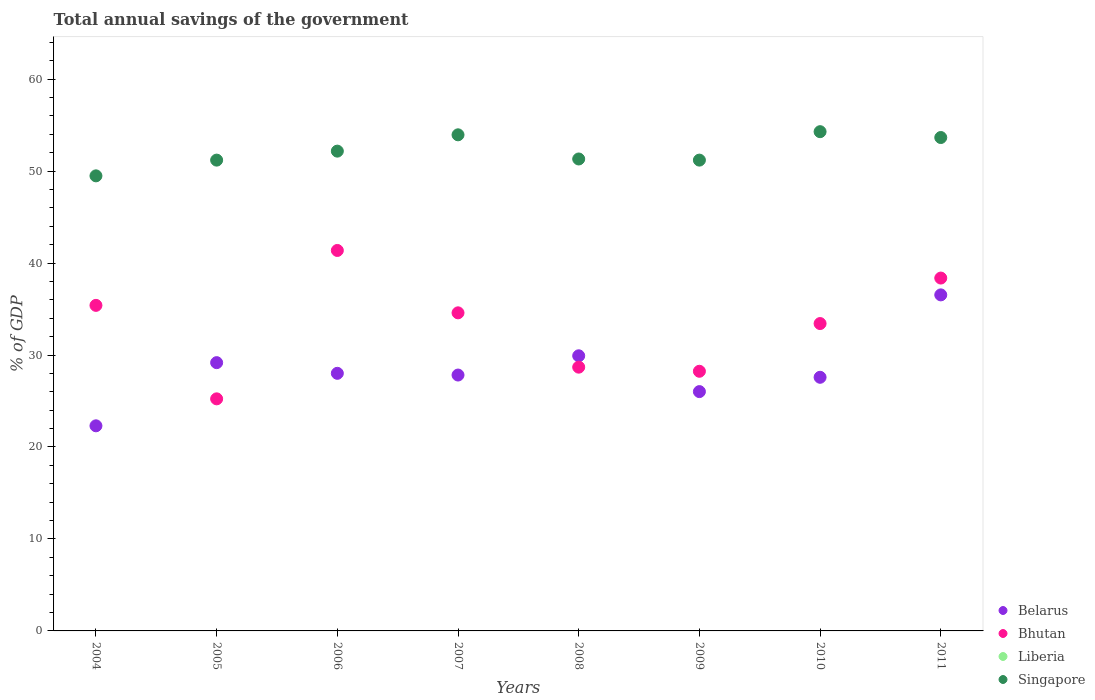How many different coloured dotlines are there?
Provide a succinct answer. 3. Is the number of dotlines equal to the number of legend labels?
Offer a very short reply. No. What is the total annual savings of the government in Singapore in 2009?
Offer a very short reply. 51.2. Across all years, what is the maximum total annual savings of the government in Singapore?
Ensure brevity in your answer.  54.29. Across all years, what is the minimum total annual savings of the government in Singapore?
Ensure brevity in your answer.  49.48. In which year was the total annual savings of the government in Bhutan maximum?
Make the answer very short. 2006. What is the difference between the total annual savings of the government in Bhutan in 2006 and that in 2007?
Ensure brevity in your answer.  6.78. What is the difference between the total annual savings of the government in Singapore in 2006 and the total annual savings of the government in Bhutan in 2008?
Your answer should be compact. 23.49. What is the average total annual savings of the government in Bhutan per year?
Keep it short and to the point. 33.16. In the year 2007, what is the difference between the total annual savings of the government in Bhutan and total annual savings of the government in Singapore?
Keep it short and to the point. -19.36. What is the ratio of the total annual savings of the government in Belarus in 2007 to that in 2011?
Your answer should be compact. 0.76. Is the total annual savings of the government in Bhutan in 2004 less than that in 2011?
Your response must be concise. Yes. Is the difference between the total annual savings of the government in Bhutan in 2008 and 2011 greater than the difference between the total annual savings of the government in Singapore in 2008 and 2011?
Your answer should be very brief. No. What is the difference between the highest and the second highest total annual savings of the government in Belarus?
Your answer should be very brief. 6.62. What is the difference between the highest and the lowest total annual savings of the government in Belarus?
Your answer should be very brief. 14.24. In how many years, is the total annual savings of the government in Liberia greater than the average total annual savings of the government in Liberia taken over all years?
Ensure brevity in your answer.  0. Is the sum of the total annual savings of the government in Singapore in 2007 and 2011 greater than the maximum total annual savings of the government in Bhutan across all years?
Offer a very short reply. Yes. Is it the case that in every year, the sum of the total annual savings of the government in Belarus and total annual savings of the government in Bhutan  is greater than the total annual savings of the government in Liberia?
Ensure brevity in your answer.  Yes. Is the total annual savings of the government in Liberia strictly greater than the total annual savings of the government in Singapore over the years?
Ensure brevity in your answer.  No. Is the total annual savings of the government in Bhutan strictly less than the total annual savings of the government in Singapore over the years?
Offer a very short reply. Yes. What is the difference between two consecutive major ticks on the Y-axis?
Ensure brevity in your answer.  10. Where does the legend appear in the graph?
Your response must be concise. Bottom right. How many legend labels are there?
Your response must be concise. 4. What is the title of the graph?
Ensure brevity in your answer.  Total annual savings of the government. What is the label or title of the Y-axis?
Ensure brevity in your answer.  % of GDP. What is the % of GDP in Belarus in 2004?
Keep it short and to the point. 22.3. What is the % of GDP in Bhutan in 2004?
Provide a succinct answer. 35.4. What is the % of GDP in Liberia in 2004?
Provide a succinct answer. 0. What is the % of GDP in Singapore in 2004?
Your answer should be very brief. 49.48. What is the % of GDP in Belarus in 2005?
Make the answer very short. 29.17. What is the % of GDP in Bhutan in 2005?
Your answer should be very brief. 25.24. What is the % of GDP in Singapore in 2005?
Your response must be concise. 51.2. What is the % of GDP of Belarus in 2006?
Your answer should be very brief. 28.01. What is the % of GDP of Bhutan in 2006?
Your response must be concise. 41.37. What is the % of GDP of Liberia in 2006?
Keep it short and to the point. 0. What is the % of GDP of Singapore in 2006?
Ensure brevity in your answer.  52.17. What is the % of GDP of Belarus in 2007?
Your response must be concise. 27.82. What is the % of GDP in Bhutan in 2007?
Keep it short and to the point. 34.59. What is the % of GDP of Singapore in 2007?
Your answer should be compact. 53.95. What is the % of GDP of Belarus in 2008?
Provide a short and direct response. 29.92. What is the % of GDP of Bhutan in 2008?
Ensure brevity in your answer.  28.68. What is the % of GDP in Singapore in 2008?
Your response must be concise. 51.32. What is the % of GDP of Belarus in 2009?
Give a very brief answer. 26.02. What is the % of GDP of Bhutan in 2009?
Offer a terse response. 28.23. What is the % of GDP of Singapore in 2009?
Your answer should be very brief. 51.2. What is the % of GDP in Belarus in 2010?
Offer a very short reply. 27.58. What is the % of GDP of Bhutan in 2010?
Offer a terse response. 33.42. What is the % of GDP of Liberia in 2010?
Make the answer very short. 0. What is the % of GDP in Singapore in 2010?
Your response must be concise. 54.29. What is the % of GDP in Belarus in 2011?
Give a very brief answer. 36.54. What is the % of GDP in Bhutan in 2011?
Ensure brevity in your answer.  38.37. What is the % of GDP of Liberia in 2011?
Offer a terse response. 0. What is the % of GDP in Singapore in 2011?
Your answer should be compact. 53.65. Across all years, what is the maximum % of GDP in Belarus?
Your answer should be compact. 36.54. Across all years, what is the maximum % of GDP of Bhutan?
Offer a very short reply. 41.37. Across all years, what is the maximum % of GDP of Singapore?
Make the answer very short. 54.29. Across all years, what is the minimum % of GDP of Belarus?
Provide a succinct answer. 22.3. Across all years, what is the minimum % of GDP in Bhutan?
Your answer should be compact. 25.24. Across all years, what is the minimum % of GDP in Singapore?
Your response must be concise. 49.48. What is the total % of GDP of Belarus in the graph?
Offer a very short reply. 227.37. What is the total % of GDP in Bhutan in the graph?
Give a very brief answer. 265.31. What is the total % of GDP of Liberia in the graph?
Your answer should be very brief. 0. What is the total % of GDP of Singapore in the graph?
Ensure brevity in your answer.  417.25. What is the difference between the % of GDP of Belarus in 2004 and that in 2005?
Give a very brief answer. -6.87. What is the difference between the % of GDP in Bhutan in 2004 and that in 2005?
Keep it short and to the point. 10.16. What is the difference between the % of GDP of Singapore in 2004 and that in 2005?
Provide a short and direct response. -1.71. What is the difference between the % of GDP in Belarus in 2004 and that in 2006?
Give a very brief answer. -5.71. What is the difference between the % of GDP of Bhutan in 2004 and that in 2006?
Give a very brief answer. -5.97. What is the difference between the % of GDP in Singapore in 2004 and that in 2006?
Offer a terse response. -2.69. What is the difference between the % of GDP in Belarus in 2004 and that in 2007?
Ensure brevity in your answer.  -5.52. What is the difference between the % of GDP of Bhutan in 2004 and that in 2007?
Offer a terse response. 0.81. What is the difference between the % of GDP of Singapore in 2004 and that in 2007?
Offer a terse response. -4.46. What is the difference between the % of GDP of Belarus in 2004 and that in 2008?
Provide a short and direct response. -7.61. What is the difference between the % of GDP in Bhutan in 2004 and that in 2008?
Make the answer very short. 6.72. What is the difference between the % of GDP of Singapore in 2004 and that in 2008?
Offer a terse response. -1.83. What is the difference between the % of GDP of Belarus in 2004 and that in 2009?
Keep it short and to the point. -3.72. What is the difference between the % of GDP of Bhutan in 2004 and that in 2009?
Ensure brevity in your answer.  7.17. What is the difference between the % of GDP in Singapore in 2004 and that in 2009?
Provide a short and direct response. -1.71. What is the difference between the % of GDP of Belarus in 2004 and that in 2010?
Make the answer very short. -5.28. What is the difference between the % of GDP in Bhutan in 2004 and that in 2010?
Ensure brevity in your answer.  1.98. What is the difference between the % of GDP in Singapore in 2004 and that in 2010?
Make the answer very short. -4.8. What is the difference between the % of GDP of Belarus in 2004 and that in 2011?
Provide a short and direct response. -14.24. What is the difference between the % of GDP of Bhutan in 2004 and that in 2011?
Provide a succinct answer. -2.97. What is the difference between the % of GDP of Singapore in 2004 and that in 2011?
Give a very brief answer. -4.17. What is the difference between the % of GDP of Belarus in 2005 and that in 2006?
Give a very brief answer. 1.16. What is the difference between the % of GDP in Bhutan in 2005 and that in 2006?
Ensure brevity in your answer.  -16.14. What is the difference between the % of GDP of Singapore in 2005 and that in 2006?
Give a very brief answer. -0.98. What is the difference between the % of GDP in Belarus in 2005 and that in 2007?
Your response must be concise. 1.35. What is the difference between the % of GDP in Bhutan in 2005 and that in 2007?
Offer a very short reply. -9.35. What is the difference between the % of GDP of Singapore in 2005 and that in 2007?
Provide a short and direct response. -2.75. What is the difference between the % of GDP in Belarus in 2005 and that in 2008?
Offer a very short reply. -0.75. What is the difference between the % of GDP in Bhutan in 2005 and that in 2008?
Offer a terse response. -3.45. What is the difference between the % of GDP of Singapore in 2005 and that in 2008?
Your answer should be compact. -0.12. What is the difference between the % of GDP of Belarus in 2005 and that in 2009?
Offer a terse response. 3.15. What is the difference between the % of GDP of Bhutan in 2005 and that in 2009?
Your answer should be very brief. -3. What is the difference between the % of GDP of Singapore in 2005 and that in 2009?
Your response must be concise. -0. What is the difference between the % of GDP in Belarus in 2005 and that in 2010?
Your answer should be compact. 1.59. What is the difference between the % of GDP of Bhutan in 2005 and that in 2010?
Make the answer very short. -8.19. What is the difference between the % of GDP of Singapore in 2005 and that in 2010?
Your answer should be compact. -3.09. What is the difference between the % of GDP of Belarus in 2005 and that in 2011?
Your answer should be compact. -7.37. What is the difference between the % of GDP in Bhutan in 2005 and that in 2011?
Ensure brevity in your answer.  -13.13. What is the difference between the % of GDP of Singapore in 2005 and that in 2011?
Offer a very short reply. -2.46. What is the difference between the % of GDP in Belarus in 2006 and that in 2007?
Your answer should be very brief. 0.19. What is the difference between the % of GDP in Bhutan in 2006 and that in 2007?
Your answer should be very brief. 6.78. What is the difference between the % of GDP of Singapore in 2006 and that in 2007?
Offer a terse response. -1.77. What is the difference between the % of GDP in Belarus in 2006 and that in 2008?
Keep it short and to the point. -1.91. What is the difference between the % of GDP of Bhutan in 2006 and that in 2008?
Provide a succinct answer. 12.69. What is the difference between the % of GDP in Singapore in 2006 and that in 2008?
Offer a terse response. 0.85. What is the difference between the % of GDP in Belarus in 2006 and that in 2009?
Provide a succinct answer. 1.99. What is the difference between the % of GDP in Bhutan in 2006 and that in 2009?
Provide a succinct answer. 13.14. What is the difference between the % of GDP of Singapore in 2006 and that in 2009?
Offer a very short reply. 0.98. What is the difference between the % of GDP of Belarus in 2006 and that in 2010?
Your response must be concise. 0.43. What is the difference between the % of GDP in Bhutan in 2006 and that in 2010?
Offer a very short reply. 7.95. What is the difference between the % of GDP of Singapore in 2006 and that in 2010?
Your response must be concise. -2.12. What is the difference between the % of GDP of Belarus in 2006 and that in 2011?
Provide a short and direct response. -8.53. What is the difference between the % of GDP of Bhutan in 2006 and that in 2011?
Your response must be concise. 3. What is the difference between the % of GDP in Singapore in 2006 and that in 2011?
Make the answer very short. -1.48. What is the difference between the % of GDP of Belarus in 2007 and that in 2008?
Your response must be concise. -2.09. What is the difference between the % of GDP in Bhutan in 2007 and that in 2008?
Make the answer very short. 5.91. What is the difference between the % of GDP of Singapore in 2007 and that in 2008?
Keep it short and to the point. 2.63. What is the difference between the % of GDP of Belarus in 2007 and that in 2009?
Offer a terse response. 1.8. What is the difference between the % of GDP of Bhutan in 2007 and that in 2009?
Provide a succinct answer. 6.35. What is the difference between the % of GDP in Singapore in 2007 and that in 2009?
Your answer should be very brief. 2.75. What is the difference between the % of GDP in Belarus in 2007 and that in 2010?
Your answer should be compact. 0.24. What is the difference between the % of GDP of Bhutan in 2007 and that in 2010?
Offer a very short reply. 1.16. What is the difference between the % of GDP in Singapore in 2007 and that in 2010?
Your answer should be compact. -0.34. What is the difference between the % of GDP of Belarus in 2007 and that in 2011?
Keep it short and to the point. -8.72. What is the difference between the % of GDP of Bhutan in 2007 and that in 2011?
Provide a succinct answer. -3.78. What is the difference between the % of GDP of Singapore in 2007 and that in 2011?
Offer a terse response. 0.29. What is the difference between the % of GDP of Belarus in 2008 and that in 2009?
Make the answer very short. 3.89. What is the difference between the % of GDP in Bhutan in 2008 and that in 2009?
Keep it short and to the point. 0.45. What is the difference between the % of GDP of Singapore in 2008 and that in 2009?
Offer a very short reply. 0.12. What is the difference between the % of GDP in Belarus in 2008 and that in 2010?
Provide a short and direct response. 2.34. What is the difference between the % of GDP in Bhutan in 2008 and that in 2010?
Offer a terse response. -4.74. What is the difference between the % of GDP of Singapore in 2008 and that in 2010?
Offer a terse response. -2.97. What is the difference between the % of GDP of Belarus in 2008 and that in 2011?
Ensure brevity in your answer.  -6.62. What is the difference between the % of GDP of Bhutan in 2008 and that in 2011?
Your answer should be very brief. -9.69. What is the difference between the % of GDP of Singapore in 2008 and that in 2011?
Make the answer very short. -2.33. What is the difference between the % of GDP in Belarus in 2009 and that in 2010?
Offer a terse response. -1.56. What is the difference between the % of GDP in Bhutan in 2009 and that in 2010?
Offer a very short reply. -5.19. What is the difference between the % of GDP of Singapore in 2009 and that in 2010?
Give a very brief answer. -3.09. What is the difference between the % of GDP in Belarus in 2009 and that in 2011?
Your answer should be compact. -10.52. What is the difference between the % of GDP in Bhutan in 2009 and that in 2011?
Provide a short and direct response. -10.14. What is the difference between the % of GDP of Singapore in 2009 and that in 2011?
Offer a terse response. -2.46. What is the difference between the % of GDP in Belarus in 2010 and that in 2011?
Provide a short and direct response. -8.96. What is the difference between the % of GDP of Bhutan in 2010 and that in 2011?
Provide a short and direct response. -4.95. What is the difference between the % of GDP in Singapore in 2010 and that in 2011?
Give a very brief answer. 0.64. What is the difference between the % of GDP of Belarus in 2004 and the % of GDP of Bhutan in 2005?
Provide a short and direct response. -2.93. What is the difference between the % of GDP of Belarus in 2004 and the % of GDP of Singapore in 2005?
Provide a succinct answer. -28.89. What is the difference between the % of GDP of Bhutan in 2004 and the % of GDP of Singapore in 2005?
Offer a very short reply. -15.79. What is the difference between the % of GDP of Belarus in 2004 and the % of GDP of Bhutan in 2006?
Your answer should be compact. -19.07. What is the difference between the % of GDP of Belarus in 2004 and the % of GDP of Singapore in 2006?
Offer a very short reply. -29.87. What is the difference between the % of GDP in Bhutan in 2004 and the % of GDP in Singapore in 2006?
Provide a short and direct response. -16.77. What is the difference between the % of GDP in Belarus in 2004 and the % of GDP in Bhutan in 2007?
Provide a short and direct response. -12.28. What is the difference between the % of GDP in Belarus in 2004 and the % of GDP in Singapore in 2007?
Ensure brevity in your answer.  -31.64. What is the difference between the % of GDP of Bhutan in 2004 and the % of GDP of Singapore in 2007?
Offer a very short reply. -18.55. What is the difference between the % of GDP in Belarus in 2004 and the % of GDP in Bhutan in 2008?
Provide a succinct answer. -6.38. What is the difference between the % of GDP of Belarus in 2004 and the % of GDP of Singapore in 2008?
Keep it short and to the point. -29.02. What is the difference between the % of GDP of Bhutan in 2004 and the % of GDP of Singapore in 2008?
Make the answer very short. -15.92. What is the difference between the % of GDP in Belarus in 2004 and the % of GDP in Bhutan in 2009?
Your answer should be compact. -5.93. What is the difference between the % of GDP in Belarus in 2004 and the % of GDP in Singapore in 2009?
Your response must be concise. -28.89. What is the difference between the % of GDP in Bhutan in 2004 and the % of GDP in Singapore in 2009?
Your answer should be very brief. -15.79. What is the difference between the % of GDP of Belarus in 2004 and the % of GDP of Bhutan in 2010?
Give a very brief answer. -11.12. What is the difference between the % of GDP in Belarus in 2004 and the % of GDP in Singapore in 2010?
Your response must be concise. -31.98. What is the difference between the % of GDP of Bhutan in 2004 and the % of GDP of Singapore in 2010?
Offer a very short reply. -18.89. What is the difference between the % of GDP of Belarus in 2004 and the % of GDP of Bhutan in 2011?
Make the answer very short. -16.07. What is the difference between the % of GDP of Belarus in 2004 and the % of GDP of Singapore in 2011?
Your response must be concise. -31.35. What is the difference between the % of GDP in Bhutan in 2004 and the % of GDP in Singapore in 2011?
Provide a succinct answer. -18.25. What is the difference between the % of GDP in Belarus in 2005 and the % of GDP in Bhutan in 2006?
Offer a very short reply. -12.2. What is the difference between the % of GDP in Belarus in 2005 and the % of GDP in Singapore in 2006?
Give a very brief answer. -23. What is the difference between the % of GDP in Bhutan in 2005 and the % of GDP in Singapore in 2006?
Ensure brevity in your answer.  -26.94. What is the difference between the % of GDP in Belarus in 2005 and the % of GDP in Bhutan in 2007?
Your answer should be compact. -5.42. What is the difference between the % of GDP in Belarus in 2005 and the % of GDP in Singapore in 2007?
Your answer should be compact. -24.78. What is the difference between the % of GDP in Bhutan in 2005 and the % of GDP in Singapore in 2007?
Offer a terse response. -28.71. What is the difference between the % of GDP of Belarus in 2005 and the % of GDP of Bhutan in 2008?
Keep it short and to the point. 0.49. What is the difference between the % of GDP of Belarus in 2005 and the % of GDP of Singapore in 2008?
Make the answer very short. -22.15. What is the difference between the % of GDP of Bhutan in 2005 and the % of GDP of Singapore in 2008?
Provide a short and direct response. -26.08. What is the difference between the % of GDP of Belarus in 2005 and the % of GDP of Bhutan in 2009?
Ensure brevity in your answer.  0.94. What is the difference between the % of GDP in Belarus in 2005 and the % of GDP in Singapore in 2009?
Offer a terse response. -22.02. What is the difference between the % of GDP in Bhutan in 2005 and the % of GDP in Singapore in 2009?
Keep it short and to the point. -25.96. What is the difference between the % of GDP in Belarus in 2005 and the % of GDP in Bhutan in 2010?
Keep it short and to the point. -4.25. What is the difference between the % of GDP of Belarus in 2005 and the % of GDP of Singapore in 2010?
Your answer should be very brief. -25.12. What is the difference between the % of GDP in Bhutan in 2005 and the % of GDP in Singapore in 2010?
Give a very brief answer. -29.05. What is the difference between the % of GDP in Belarus in 2005 and the % of GDP in Bhutan in 2011?
Your response must be concise. -9.2. What is the difference between the % of GDP of Belarus in 2005 and the % of GDP of Singapore in 2011?
Offer a terse response. -24.48. What is the difference between the % of GDP of Bhutan in 2005 and the % of GDP of Singapore in 2011?
Make the answer very short. -28.42. What is the difference between the % of GDP of Belarus in 2006 and the % of GDP of Bhutan in 2007?
Give a very brief answer. -6.58. What is the difference between the % of GDP of Belarus in 2006 and the % of GDP of Singapore in 2007?
Provide a succinct answer. -25.94. What is the difference between the % of GDP of Bhutan in 2006 and the % of GDP of Singapore in 2007?
Your answer should be compact. -12.57. What is the difference between the % of GDP of Belarus in 2006 and the % of GDP of Bhutan in 2008?
Keep it short and to the point. -0.67. What is the difference between the % of GDP in Belarus in 2006 and the % of GDP in Singapore in 2008?
Provide a short and direct response. -23.31. What is the difference between the % of GDP in Bhutan in 2006 and the % of GDP in Singapore in 2008?
Provide a succinct answer. -9.95. What is the difference between the % of GDP of Belarus in 2006 and the % of GDP of Bhutan in 2009?
Provide a succinct answer. -0.22. What is the difference between the % of GDP in Belarus in 2006 and the % of GDP in Singapore in 2009?
Provide a short and direct response. -23.18. What is the difference between the % of GDP in Bhutan in 2006 and the % of GDP in Singapore in 2009?
Provide a succinct answer. -9.82. What is the difference between the % of GDP in Belarus in 2006 and the % of GDP in Bhutan in 2010?
Provide a succinct answer. -5.41. What is the difference between the % of GDP of Belarus in 2006 and the % of GDP of Singapore in 2010?
Your response must be concise. -26.28. What is the difference between the % of GDP in Bhutan in 2006 and the % of GDP in Singapore in 2010?
Make the answer very short. -12.92. What is the difference between the % of GDP in Belarus in 2006 and the % of GDP in Bhutan in 2011?
Keep it short and to the point. -10.36. What is the difference between the % of GDP in Belarus in 2006 and the % of GDP in Singapore in 2011?
Your answer should be very brief. -25.64. What is the difference between the % of GDP of Bhutan in 2006 and the % of GDP of Singapore in 2011?
Your answer should be very brief. -12.28. What is the difference between the % of GDP in Belarus in 2007 and the % of GDP in Bhutan in 2008?
Ensure brevity in your answer.  -0.86. What is the difference between the % of GDP of Belarus in 2007 and the % of GDP of Singapore in 2008?
Provide a short and direct response. -23.5. What is the difference between the % of GDP in Bhutan in 2007 and the % of GDP in Singapore in 2008?
Offer a terse response. -16.73. What is the difference between the % of GDP of Belarus in 2007 and the % of GDP of Bhutan in 2009?
Make the answer very short. -0.41. What is the difference between the % of GDP of Belarus in 2007 and the % of GDP of Singapore in 2009?
Provide a succinct answer. -23.37. What is the difference between the % of GDP of Bhutan in 2007 and the % of GDP of Singapore in 2009?
Provide a short and direct response. -16.61. What is the difference between the % of GDP of Belarus in 2007 and the % of GDP of Bhutan in 2010?
Provide a succinct answer. -5.6. What is the difference between the % of GDP of Belarus in 2007 and the % of GDP of Singapore in 2010?
Provide a short and direct response. -26.46. What is the difference between the % of GDP of Bhutan in 2007 and the % of GDP of Singapore in 2010?
Your response must be concise. -19.7. What is the difference between the % of GDP in Belarus in 2007 and the % of GDP in Bhutan in 2011?
Make the answer very short. -10.55. What is the difference between the % of GDP in Belarus in 2007 and the % of GDP in Singapore in 2011?
Offer a very short reply. -25.83. What is the difference between the % of GDP of Bhutan in 2007 and the % of GDP of Singapore in 2011?
Your response must be concise. -19.06. What is the difference between the % of GDP in Belarus in 2008 and the % of GDP in Bhutan in 2009?
Offer a very short reply. 1.68. What is the difference between the % of GDP of Belarus in 2008 and the % of GDP of Singapore in 2009?
Your answer should be very brief. -21.28. What is the difference between the % of GDP of Bhutan in 2008 and the % of GDP of Singapore in 2009?
Provide a succinct answer. -22.51. What is the difference between the % of GDP in Belarus in 2008 and the % of GDP in Bhutan in 2010?
Offer a terse response. -3.51. What is the difference between the % of GDP of Belarus in 2008 and the % of GDP of Singapore in 2010?
Your answer should be compact. -24.37. What is the difference between the % of GDP of Bhutan in 2008 and the % of GDP of Singapore in 2010?
Make the answer very short. -25.61. What is the difference between the % of GDP in Belarus in 2008 and the % of GDP in Bhutan in 2011?
Your answer should be very brief. -8.45. What is the difference between the % of GDP in Belarus in 2008 and the % of GDP in Singapore in 2011?
Keep it short and to the point. -23.74. What is the difference between the % of GDP in Bhutan in 2008 and the % of GDP in Singapore in 2011?
Offer a very short reply. -24.97. What is the difference between the % of GDP in Belarus in 2009 and the % of GDP in Bhutan in 2010?
Provide a succinct answer. -7.4. What is the difference between the % of GDP of Belarus in 2009 and the % of GDP of Singapore in 2010?
Give a very brief answer. -28.26. What is the difference between the % of GDP of Bhutan in 2009 and the % of GDP of Singapore in 2010?
Ensure brevity in your answer.  -26.05. What is the difference between the % of GDP in Belarus in 2009 and the % of GDP in Bhutan in 2011?
Provide a short and direct response. -12.35. What is the difference between the % of GDP of Belarus in 2009 and the % of GDP of Singapore in 2011?
Make the answer very short. -27.63. What is the difference between the % of GDP of Bhutan in 2009 and the % of GDP of Singapore in 2011?
Give a very brief answer. -25.42. What is the difference between the % of GDP of Belarus in 2010 and the % of GDP of Bhutan in 2011?
Make the answer very short. -10.79. What is the difference between the % of GDP in Belarus in 2010 and the % of GDP in Singapore in 2011?
Your response must be concise. -26.07. What is the difference between the % of GDP in Bhutan in 2010 and the % of GDP in Singapore in 2011?
Make the answer very short. -20.23. What is the average % of GDP of Belarus per year?
Provide a short and direct response. 28.42. What is the average % of GDP in Bhutan per year?
Give a very brief answer. 33.16. What is the average % of GDP in Liberia per year?
Make the answer very short. 0. What is the average % of GDP of Singapore per year?
Provide a short and direct response. 52.16. In the year 2004, what is the difference between the % of GDP in Belarus and % of GDP in Bhutan?
Provide a succinct answer. -13.1. In the year 2004, what is the difference between the % of GDP of Belarus and % of GDP of Singapore?
Your response must be concise. -27.18. In the year 2004, what is the difference between the % of GDP in Bhutan and % of GDP in Singapore?
Provide a short and direct response. -14.08. In the year 2005, what is the difference between the % of GDP of Belarus and % of GDP of Bhutan?
Give a very brief answer. 3.94. In the year 2005, what is the difference between the % of GDP in Belarus and % of GDP in Singapore?
Make the answer very short. -22.02. In the year 2005, what is the difference between the % of GDP in Bhutan and % of GDP in Singapore?
Keep it short and to the point. -25.96. In the year 2006, what is the difference between the % of GDP of Belarus and % of GDP of Bhutan?
Offer a terse response. -13.36. In the year 2006, what is the difference between the % of GDP in Belarus and % of GDP in Singapore?
Provide a succinct answer. -24.16. In the year 2006, what is the difference between the % of GDP of Bhutan and % of GDP of Singapore?
Offer a terse response. -10.8. In the year 2007, what is the difference between the % of GDP in Belarus and % of GDP in Bhutan?
Make the answer very short. -6.76. In the year 2007, what is the difference between the % of GDP in Belarus and % of GDP in Singapore?
Provide a succinct answer. -26.12. In the year 2007, what is the difference between the % of GDP in Bhutan and % of GDP in Singapore?
Provide a succinct answer. -19.36. In the year 2008, what is the difference between the % of GDP of Belarus and % of GDP of Bhutan?
Keep it short and to the point. 1.24. In the year 2008, what is the difference between the % of GDP in Belarus and % of GDP in Singapore?
Your response must be concise. -21.4. In the year 2008, what is the difference between the % of GDP in Bhutan and % of GDP in Singapore?
Give a very brief answer. -22.64. In the year 2009, what is the difference between the % of GDP of Belarus and % of GDP of Bhutan?
Give a very brief answer. -2.21. In the year 2009, what is the difference between the % of GDP in Belarus and % of GDP in Singapore?
Ensure brevity in your answer.  -25.17. In the year 2009, what is the difference between the % of GDP of Bhutan and % of GDP of Singapore?
Provide a succinct answer. -22.96. In the year 2010, what is the difference between the % of GDP in Belarus and % of GDP in Bhutan?
Offer a very short reply. -5.84. In the year 2010, what is the difference between the % of GDP in Belarus and % of GDP in Singapore?
Your response must be concise. -26.71. In the year 2010, what is the difference between the % of GDP in Bhutan and % of GDP in Singapore?
Make the answer very short. -20.86. In the year 2011, what is the difference between the % of GDP in Belarus and % of GDP in Bhutan?
Ensure brevity in your answer.  -1.83. In the year 2011, what is the difference between the % of GDP in Belarus and % of GDP in Singapore?
Ensure brevity in your answer.  -17.11. In the year 2011, what is the difference between the % of GDP in Bhutan and % of GDP in Singapore?
Ensure brevity in your answer.  -15.28. What is the ratio of the % of GDP of Belarus in 2004 to that in 2005?
Give a very brief answer. 0.76. What is the ratio of the % of GDP in Bhutan in 2004 to that in 2005?
Provide a short and direct response. 1.4. What is the ratio of the % of GDP in Singapore in 2004 to that in 2005?
Offer a terse response. 0.97. What is the ratio of the % of GDP of Belarus in 2004 to that in 2006?
Offer a very short reply. 0.8. What is the ratio of the % of GDP in Bhutan in 2004 to that in 2006?
Give a very brief answer. 0.86. What is the ratio of the % of GDP of Singapore in 2004 to that in 2006?
Your answer should be very brief. 0.95. What is the ratio of the % of GDP in Belarus in 2004 to that in 2007?
Provide a short and direct response. 0.8. What is the ratio of the % of GDP of Bhutan in 2004 to that in 2007?
Offer a very short reply. 1.02. What is the ratio of the % of GDP of Singapore in 2004 to that in 2007?
Give a very brief answer. 0.92. What is the ratio of the % of GDP in Belarus in 2004 to that in 2008?
Make the answer very short. 0.75. What is the ratio of the % of GDP in Bhutan in 2004 to that in 2008?
Provide a short and direct response. 1.23. What is the ratio of the % of GDP of Singapore in 2004 to that in 2008?
Give a very brief answer. 0.96. What is the ratio of the % of GDP in Bhutan in 2004 to that in 2009?
Your response must be concise. 1.25. What is the ratio of the % of GDP in Singapore in 2004 to that in 2009?
Make the answer very short. 0.97. What is the ratio of the % of GDP of Belarus in 2004 to that in 2010?
Provide a succinct answer. 0.81. What is the ratio of the % of GDP in Bhutan in 2004 to that in 2010?
Keep it short and to the point. 1.06. What is the ratio of the % of GDP of Singapore in 2004 to that in 2010?
Keep it short and to the point. 0.91. What is the ratio of the % of GDP of Belarus in 2004 to that in 2011?
Provide a succinct answer. 0.61. What is the ratio of the % of GDP of Bhutan in 2004 to that in 2011?
Your response must be concise. 0.92. What is the ratio of the % of GDP of Singapore in 2004 to that in 2011?
Offer a terse response. 0.92. What is the ratio of the % of GDP in Belarus in 2005 to that in 2006?
Offer a terse response. 1.04. What is the ratio of the % of GDP in Bhutan in 2005 to that in 2006?
Keep it short and to the point. 0.61. What is the ratio of the % of GDP of Singapore in 2005 to that in 2006?
Your answer should be very brief. 0.98. What is the ratio of the % of GDP in Belarus in 2005 to that in 2007?
Your answer should be very brief. 1.05. What is the ratio of the % of GDP in Bhutan in 2005 to that in 2007?
Your response must be concise. 0.73. What is the ratio of the % of GDP of Singapore in 2005 to that in 2007?
Your response must be concise. 0.95. What is the ratio of the % of GDP of Belarus in 2005 to that in 2008?
Ensure brevity in your answer.  0.98. What is the ratio of the % of GDP of Bhutan in 2005 to that in 2008?
Your response must be concise. 0.88. What is the ratio of the % of GDP in Singapore in 2005 to that in 2008?
Provide a short and direct response. 1. What is the ratio of the % of GDP in Belarus in 2005 to that in 2009?
Provide a short and direct response. 1.12. What is the ratio of the % of GDP in Bhutan in 2005 to that in 2009?
Offer a very short reply. 0.89. What is the ratio of the % of GDP in Singapore in 2005 to that in 2009?
Keep it short and to the point. 1. What is the ratio of the % of GDP in Belarus in 2005 to that in 2010?
Give a very brief answer. 1.06. What is the ratio of the % of GDP in Bhutan in 2005 to that in 2010?
Give a very brief answer. 0.76. What is the ratio of the % of GDP in Singapore in 2005 to that in 2010?
Your response must be concise. 0.94. What is the ratio of the % of GDP in Belarus in 2005 to that in 2011?
Your response must be concise. 0.8. What is the ratio of the % of GDP in Bhutan in 2005 to that in 2011?
Your response must be concise. 0.66. What is the ratio of the % of GDP in Singapore in 2005 to that in 2011?
Provide a short and direct response. 0.95. What is the ratio of the % of GDP in Belarus in 2006 to that in 2007?
Ensure brevity in your answer.  1.01. What is the ratio of the % of GDP in Bhutan in 2006 to that in 2007?
Your response must be concise. 1.2. What is the ratio of the % of GDP of Singapore in 2006 to that in 2007?
Provide a short and direct response. 0.97. What is the ratio of the % of GDP in Belarus in 2006 to that in 2008?
Offer a very short reply. 0.94. What is the ratio of the % of GDP of Bhutan in 2006 to that in 2008?
Offer a very short reply. 1.44. What is the ratio of the % of GDP in Singapore in 2006 to that in 2008?
Your answer should be compact. 1.02. What is the ratio of the % of GDP of Belarus in 2006 to that in 2009?
Keep it short and to the point. 1.08. What is the ratio of the % of GDP in Bhutan in 2006 to that in 2009?
Offer a terse response. 1.47. What is the ratio of the % of GDP of Singapore in 2006 to that in 2009?
Make the answer very short. 1.02. What is the ratio of the % of GDP in Belarus in 2006 to that in 2010?
Make the answer very short. 1.02. What is the ratio of the % of GDP of Bhutan in 2006 to that in 2010?
Your answer should be compact. 1.24. What is the ratio of the % of GDP in Singapore in 2006 to that in 2010?
Your answer should be very brief. 0.96. What is the ratio of the % of GDP in Belarus in 2006 to that in 2011?
Provide a succinct answer. 0.77. What is the ratio of the % of GDP of Bhutan in 2006 to that in 2011?
Keep it short and to the point. 1.08. What is the ratio of the % of GDP of Singapore in 2006 to that in 2011?
Make the answer very short. 0.97. What is the ratio of the % of GDP of Belarus in 2007 to that in 2008?
Your answer should be very brief. 0.93. What is the ratio of the % of GDP in Bhutan in 2007 to that in 2008?
Make the answer very short. 1.21. What is the ratio of the % of GDP of Singapore in 2007 to that in 2008?
Keep it short and to the point. 1.05. What is the ratio of the % of GDP of Belarus in 2007 to that in 2009?
Ensure brevity in your answer.  1.07. What is the ratio of the % of GDP in Bhutan in 2007 to that in 2009?
Offer a very short reply. 1.23. What is the ratio of the % of GDP of Singapore in 2007 to that in 2009?
Provide a short and direct response. 1.05. What is the ratio of the % of GDP in Belarus in 2007 to that in 2010?
Offer a terse response. 1.01. What is the ratio of the % of GDP of Bhutan in 2007 to that in 2010?
Ensure brevity in your answer.  1.03. What is the ratio of the % of GDP of Singapore in 2007 to that in 2010?
Make the answer very short. 0.99. What is the ratio of the % of GDP in Belarus in 2007 to that in 2011?
Provide a short and direct response. 0.76. What is the ratio of the % of GDP of Bhutan in 2007 to that in 2011?
Offer a very short reply. 0.9. What is the ratio of the % of GDP in Belarus in 2008 to that in 2009?
Ensure brevity in your answer.  1.15. What is the ratio of the % of GDP in Bhutan in 2008 to that in 2009?
Keep it short and to the point. 1.02. What is the ratio of the % of GDP in Singapore in 2008 to that in 2009?
Provide a short and direct response. 1. What is the ratio of the % of GDP of Belarus in 2008 to that in 2010?
Keep it short and to the point. 1.08. What is the ratio of the % of GDP of Bhutan in 2008 to that in 2010?
Provide a short and direct response. 0.86. What is the ratio of the % of GDP of Singapore in 2008 to that in 2010?
Keep it short and to the point. 0.95. What is the ratio of the % of GDP of Belarus in 2008 to that in 2011?
Provide a short and direct response. 0.82. What is the ratio of the % of GDP in Bhutan in 2008 to that in 2011?
Keep it short and to the point. 0.75. What is the ratio of the % of GDP of Singapore in 2008 to that in 2011?
Offer a terse response. 0.96. What is the ratio of the % of GDP in Belarus in 2009 to that in 2010?
Your answer should be very brief. 0.94. What is the ratio of the % of GDP in Bhutan in 2009 to that in 2010?
Offer a terse response. 0.84. What is the ratio of the % of GDP of Singapore in 2009 to that in 2010?
Your answer should be very brief. 0.94. What is the ratio of the % of GDP of Belarus in 2009 to that in 2011?
Give a very brief answer. 0.71. What is the ratio of the % of GDP in Bhutan in 2009 to that in 2011?
Keep it short and to the point. 0.74. What is the ratio of the % of GDP of Singapore in 2009 to that in 2011?
Give a very brief answer. 0.95. What is the ratio of the % of GDP in Belarus in 2010 to that in 2011?
Ensure brevity in your answer.  0.75. What is the ratio of the % of GDP in Bhutan in 2010 to that in 2011?
Keep it short and to the point. 0.87. What is the ratio of the % of GDP in Singapore in 2010 to that in 2011?
Keep it short and to the point. 1.01. What is the difference between the highest and the second highest % of GDP of Belarus?
Offer a terse response. 6.62. What is the difference between the highest and the second highest % of GDP in Bhutan?
Provide a short and direct response. 3. What is the difference between the highest and the second highest % of GDP in Singapore?
Make the answer very short. 0.34. What is the difference between the highest and the lowest % of GDP of Belarus?
Keep it short and to the point. 14.24. What is the difference between the highest and the lowest % of GDP of Bhutan?
Make the answer very short. 16.14. What is the difference between the highest and the lowest % of GDP of Singapore?
Give a very brief answer. 4.8. 